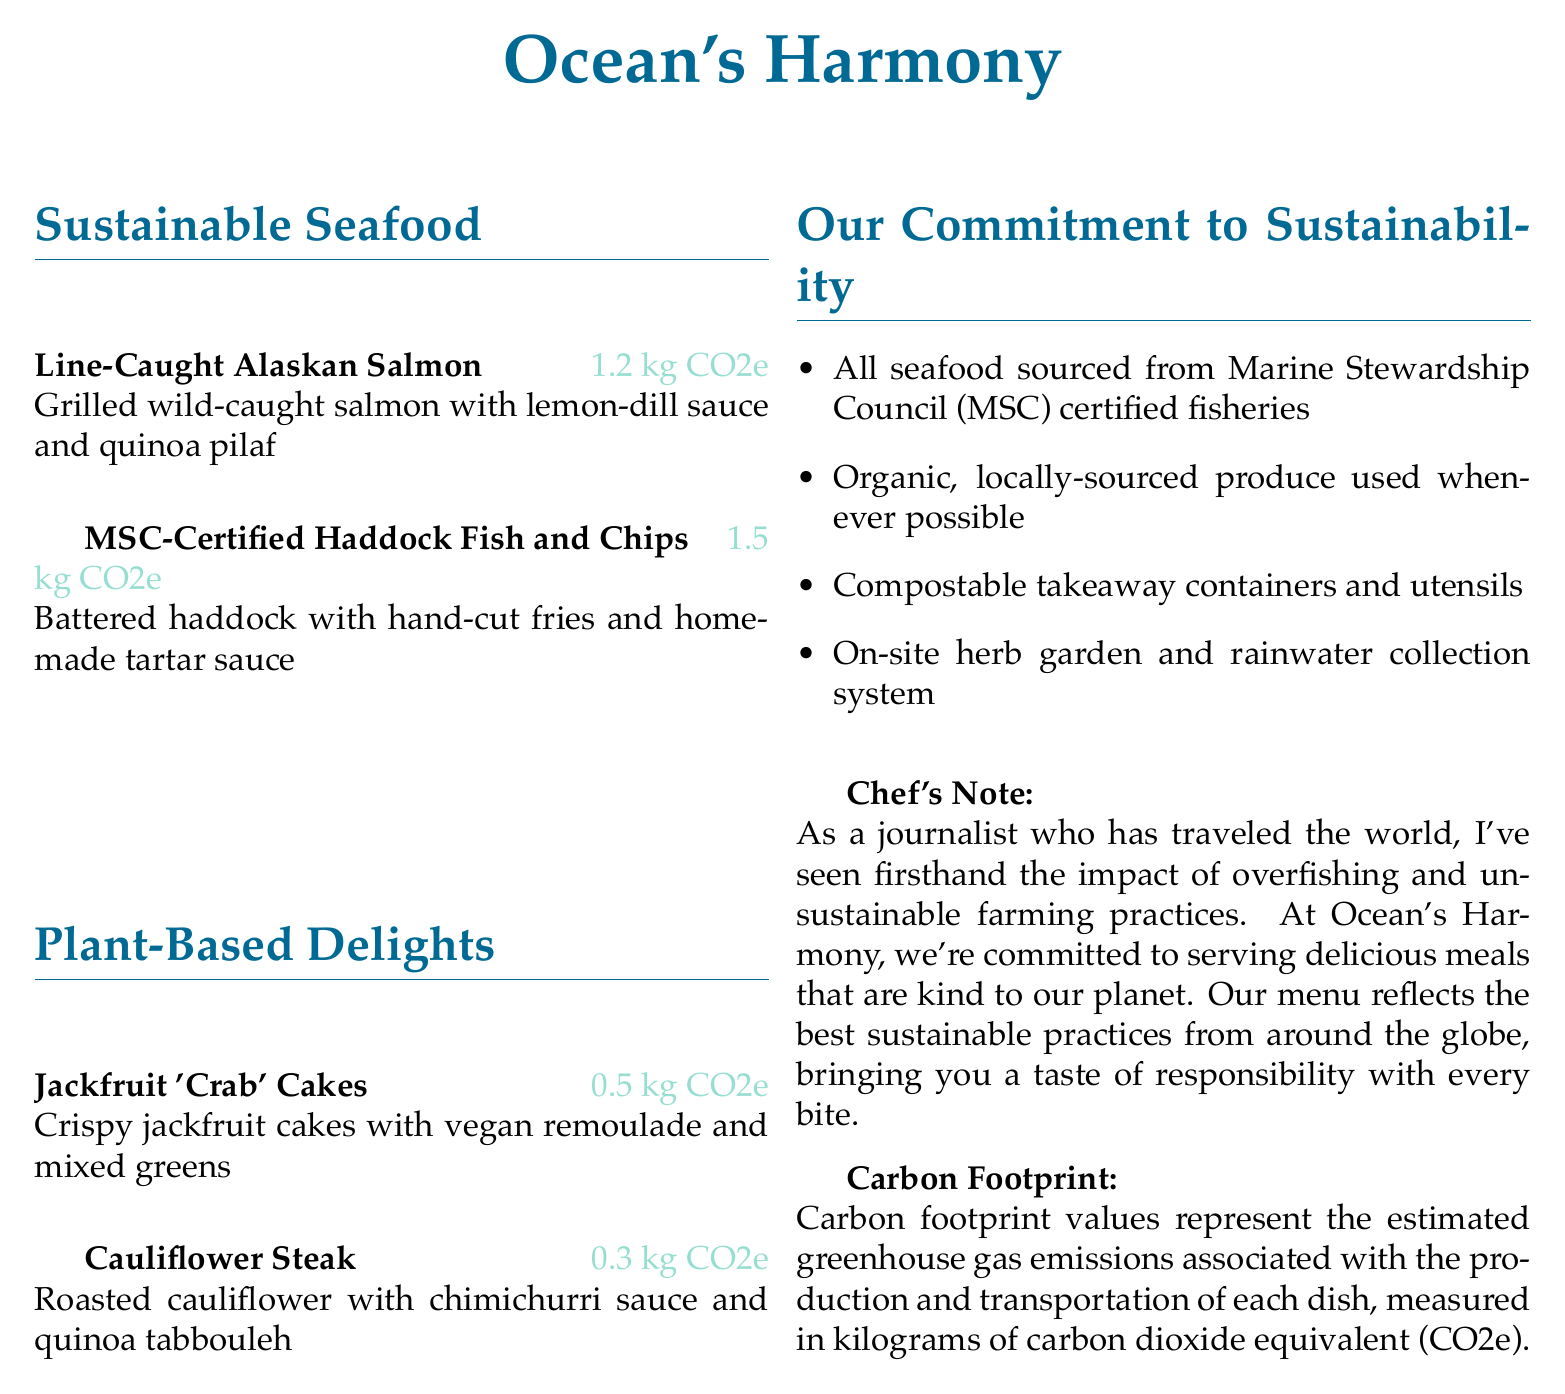What is the restaurant's name? The name of the restaurant is presented at the top of the menu as "Ocean's Harmony."
Answer: Ocean's Harmony How many kg CO2e does the Line-Caught Alaskan Salmon produce? The carbon footprint for each dish is specifically listed next to it, with Line-Caught Alaskan Salmon showing 1.2 kg CO2e.
Answer: 1.2 kg CO2e What type of sauce is served with the Cauliflower Steak? The menu provides specific details about each dish, mentioning that the Cauliflower Steak is served with chimichurri sauce.
Answer: chimichurri sauce Which fish is MSC-Certified? The menu identifies the MSC-Certified fish as Haddock in the dish titled "MSC-Certified Haddock Fish and Chips."
Answer: Haddock What is the carbon footprint of the Jackfruit 'Crab' Cakes? The carbon footprint value next to the Jackfruit 'Crab' Cakes indicates 0.5 kg CO2e.
Answer: 0.5 kg CO2e What commitment to sustainability does the restaurant make regarding seafood sourcing? The menu notes that all seafood is sourced from Marine Stewardship Council (MSC) certified fisheries, indicating a commitment to responsible sourcing.
Answer: MSC certified fisheries What is included in the dish "Cauliflower Steak"? The menu describes the ingredients of the Cauliflower Steak, which includes roasted cauliflower and quinoa tabbouleh.
Answer: roasted cauliflower and quinoa tabbouleh How are takeaway containers managed at the restaurant? The menu lists that the restaurant uses compostable takeaway containers and utensils as part of their sustainability practices.
Answer: compostable containers and utensils 